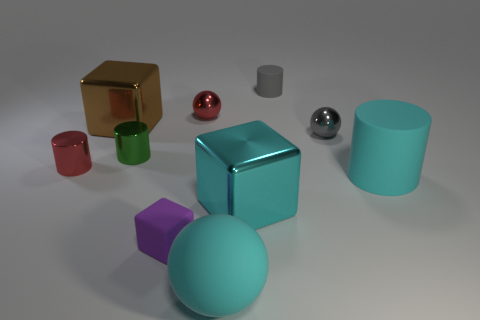What is the color of the matte object that is both to the right of the large cyan ball and to the left of the cyan cylinder? gray 